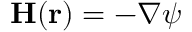<formula> <loc_0><loc_0><loc_500><loc_500>{ H } ( { r } ) = - \nabla \psi</formula> 